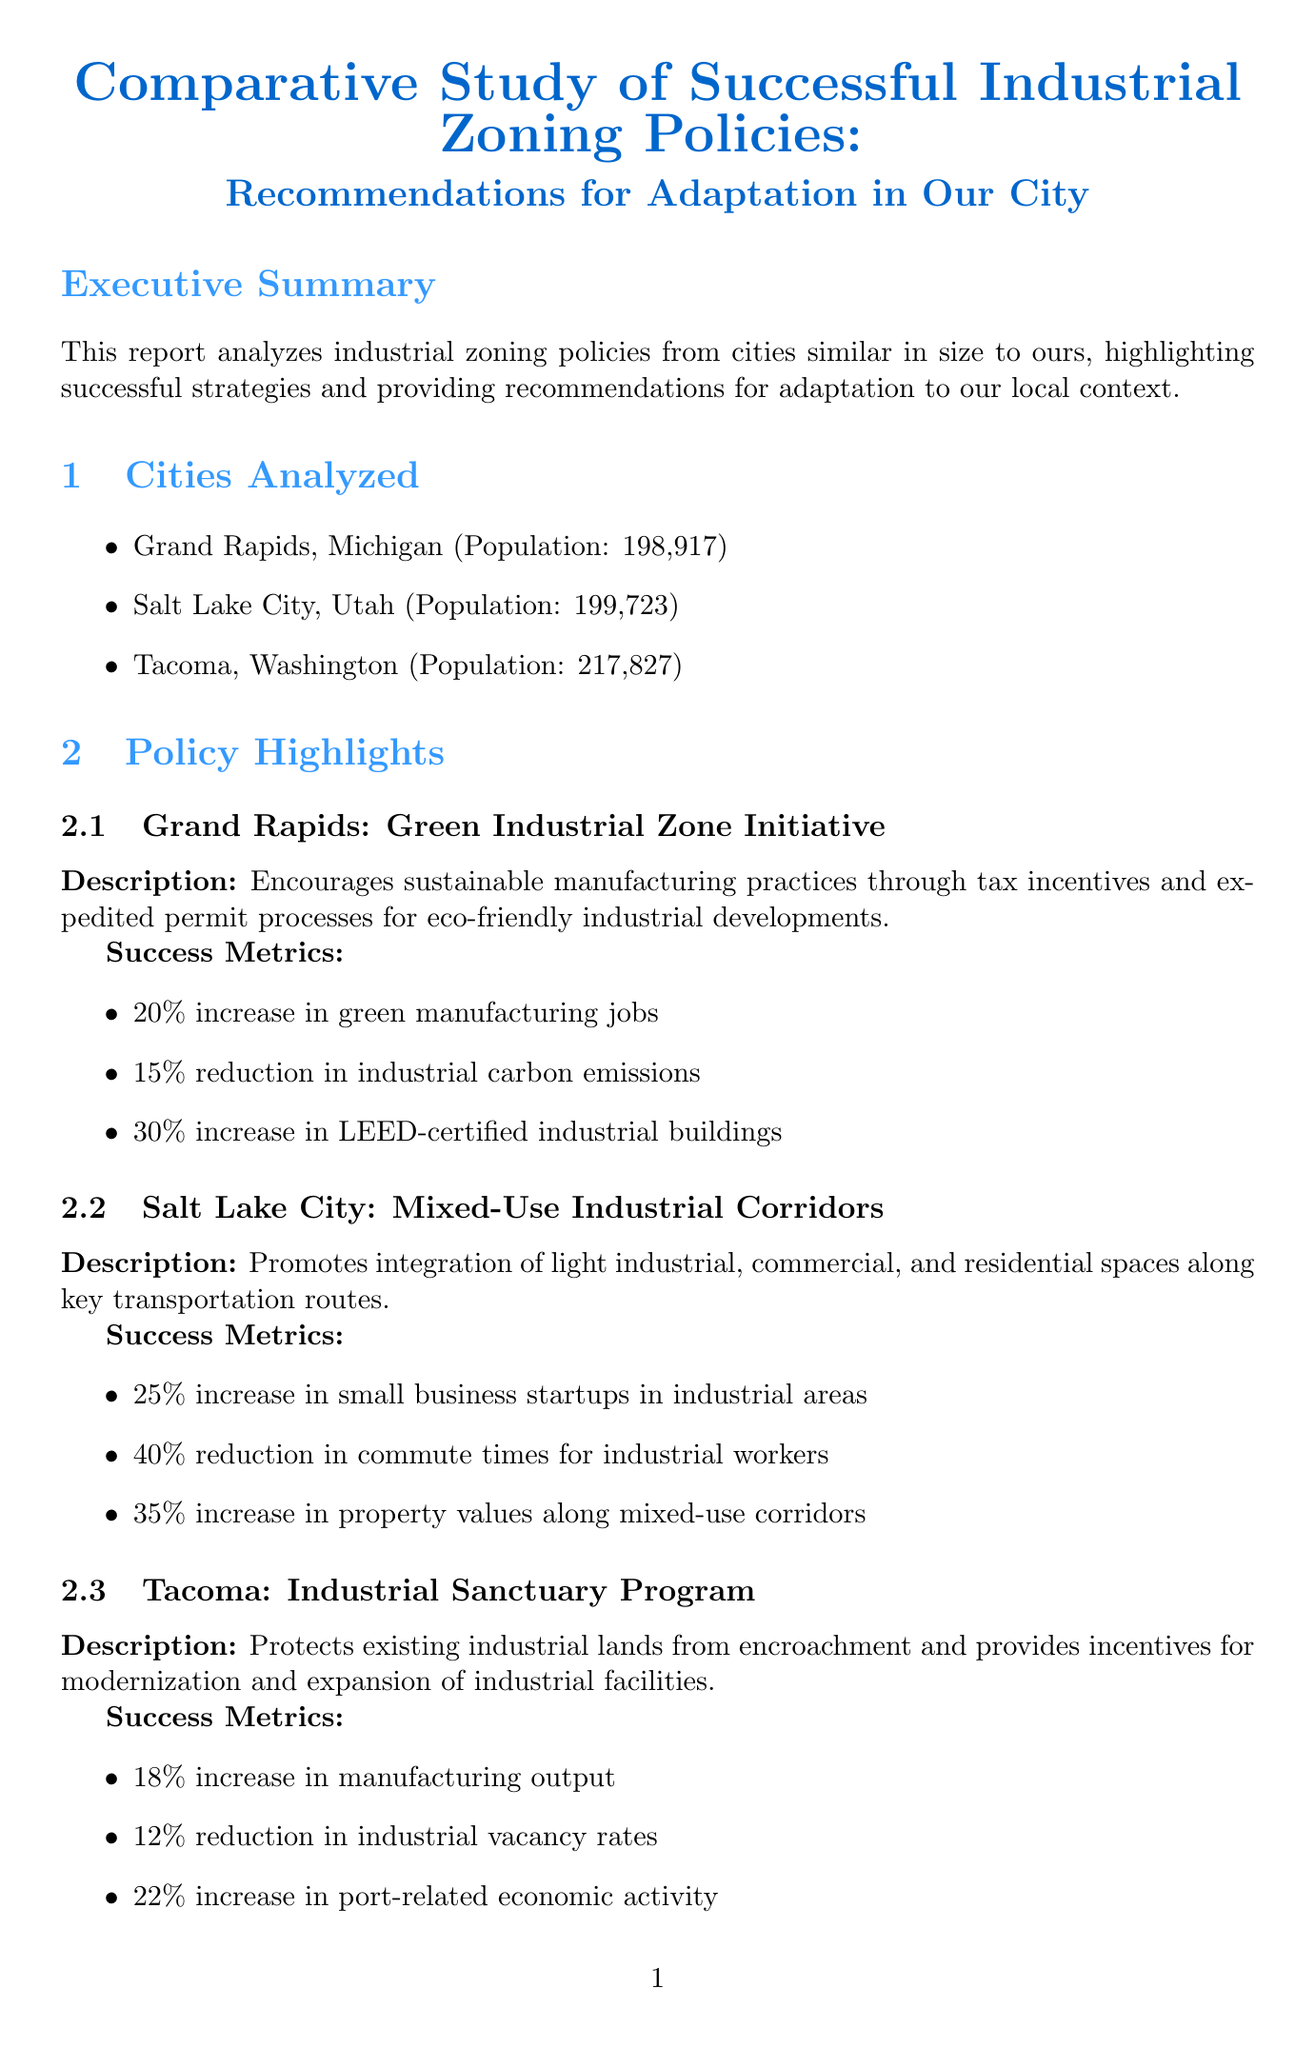What is the title of the report? The title of the report is a clear label indicating the subject under discussion.
Answer: Comparative Study of Successful Industrial Zoning Policies: Recommendations for Adaptation in Our City What is the key policy of Salt Lake City? This question looks for specific information regarding Salt Lake City's policy as mentioned in the document.
Answer: Mixed-Use Industrial Corridors What is the estimated cost of policy development? This question seeks a specific figure noted in the budget considerations section of the report.
Answer: $500,000 Which city implemented the Industrial Sanctuary Program? This question requires identifying the city associated with a specific zoning policy in the report.
Answer: Tacoma What is the potential impact of adopting Grand Rapids’ policy? This question asks for the anticipated outcomes of adapting a specific policy for the local context according to the report.
Answer: Attract eco-friendly businesses and improve environmental outcomes while boosting economic growth How long is the implementation phase expected to last? This question requires understanding the timeline details provided within the report's implementation section.
Answer: Ongoing What percentage increase in small business startups was noted in Salt Lake City? This question focuses on extracting a success metric related to Salt Lake City's policy findings.
Answer: 25% What agency is identified as a key stakeholder? This question seeks specific information regarding one of the important organizations involved in the policy process.
Answer: Chamber of Commerce 